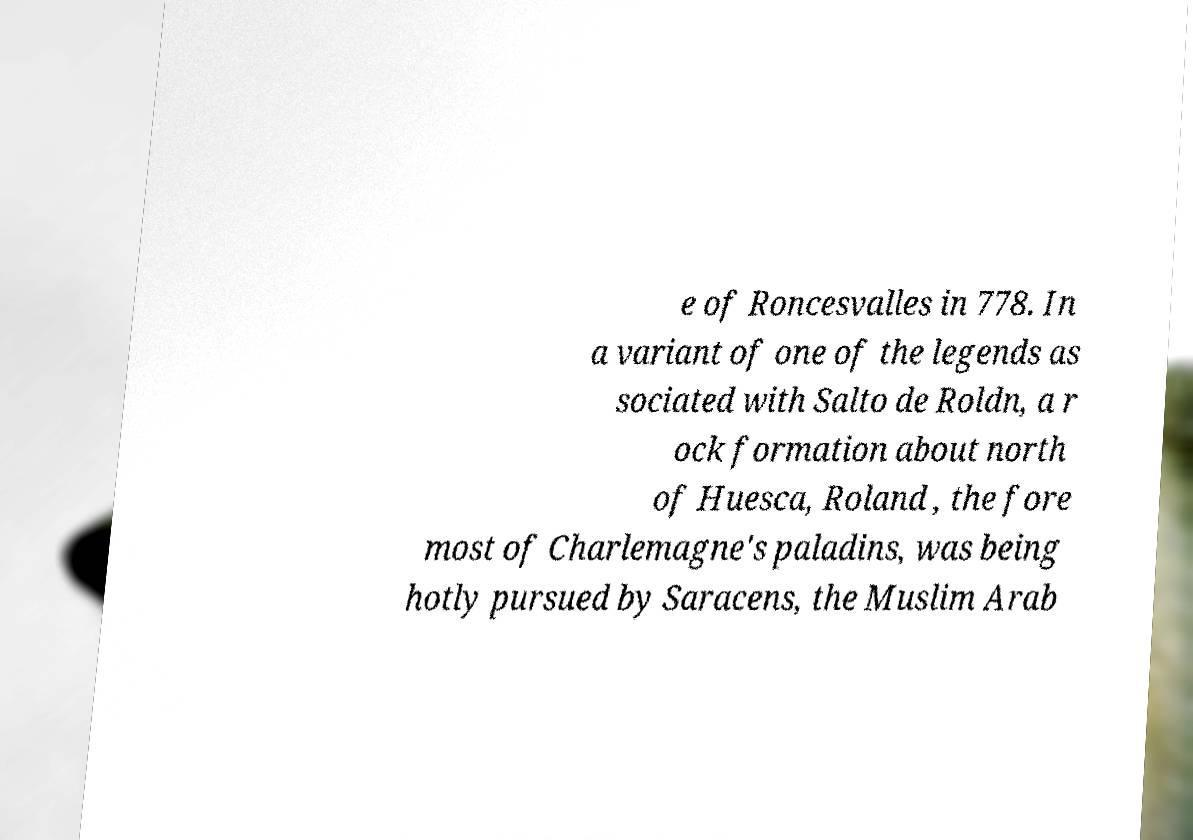Could you extract and type out the text from this image? e of Roncesvalles in 778. In a variant of one of the legends as sociated with Salto de Roldn, a r ock formation about north of Huesca, Roland , the fore most of Charlemagne's paladins, was being hotly pursued by Saracens, the Muslim Arab 